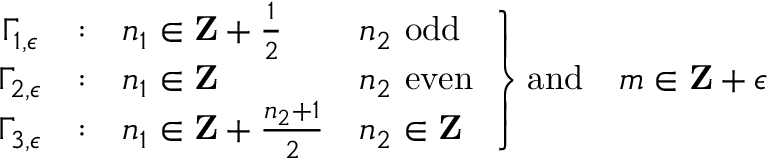Convert formula to latex. <formula><loc_0><loc_0><loc_500><loc_500>\begin{array} { c c l l } { { \Gamma _ { 1 , \epsilon } } } & { \colon } & { { n _ { 1 } \in { Z } + { \frac { 1 } { 2 } } } } & { { n _ { 2 } \ o d d } } \\ { { \Gamma _ { 2 , \epsilon } } } & { \colon } & { { n _ { 1 } \in { Z } } } & { { n _ { 2 } \ e v e n } } \\ { { \Gamma _ { 3 , \epsilon } } } & { \colon } & { { n _ { 1 } \in { Z } + { \frac { n _ { 2 } + 1 } { 2 } } } } & { { n _ { 2 } \in { Z } } } \end{array} \right \} a n d \quad m \in { Z } + \epsilon</formula> 